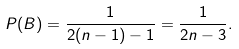Convert formula to latex. <formula><loc_0><loc_0><loc_500><loc_500>P ( B ) = \frac { 1 } { 2 ( n - 1 ) - 1 } = \frac { 1 } { 2 n - 3 } .</formula> 